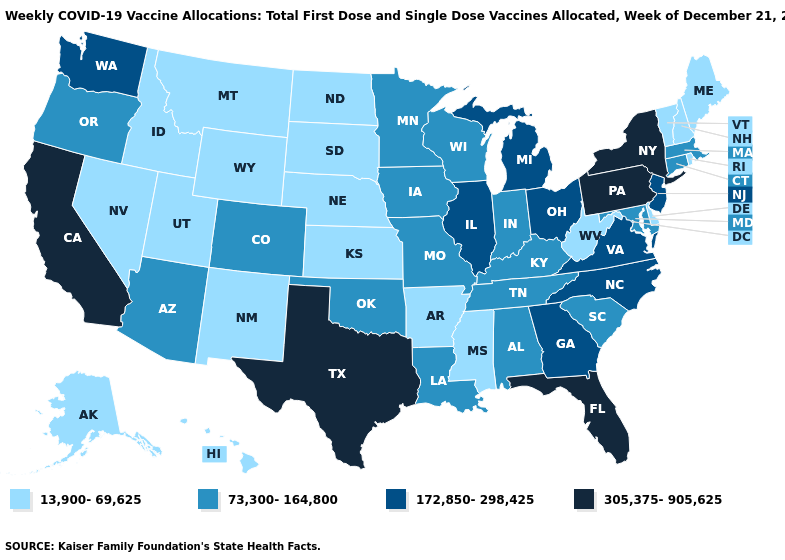Name the states that have a value in the range 13,900-69,625?
Give a very brief answer. Alaska, Arkansas, Delaware, Hawaii, Idaho, Kansas, Maine, Mississippi, Montana, Nebraska, Nevada, New Hampshire, New Mexico, North Dakota, Rhode Island, South Dakota, Utah, Vermont, West Virginia, Wyoming. What is the value of New Mexico?
Write a very short answer. 13,900-69,625. What is the highest value in the West ?
Be succinct. 305,375-905,625. Does the first symbol in the legend represent the smallest category?
Quick response, please. Yes. Among the states that border Iowa , does Illinois have the lowest value?
Quick response, please. No. What is the value of Texas?
Answer briefly. 305,375-905,625. Name the states that have a value in the range 13,900-69,625?
Quick response, please. Alaska, Arkansas, Delaware, Hawaii, Idaho, Kansas, Maine, Mississippi, Montana, Nebraska, Nevada, New Hampshire, New Mexico, North Dakota, Rhode Island, South Dakota, Utah, Vermont, West Virginia, Wyoming. What is the highest value in the Northeast ?
Give a very brief answer. 305,375-905,625. What is the highest value in states that border North Carolina?
Short answer required. 172,850-298,425. Name the states that have a value in the range 13,900-69,625?
Give a very brief answer. Alaska, Arkansas, Delaware, Hawaii, Idaho, Kansas, Maine, Mississippi, Montana, Nebraska, Nevada, New Hampshire, New Mexico, North Dakota, Rhode Island, South Dakota, Utah, Vermont, West Virginia, Wyoming. Does West Virginia have the lowest value in the USA?
Be succinct. Yes. What is the value of Texas?
Short answer required. 305,375-905,625. Among the states that border Virginia , does North Carolina have the highest value?
Quick response, please. Yes. Which states have the lowest value in the MidWest?
Give a very brief answer. Kansas, Nebraska, North Dakota, South Dakota. What is the value of New Hampshire?
Give a very brief answer. 13,900-69,625. 